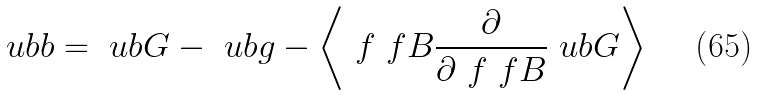<formula> <loc_0><loc_0><loc_500><loc_500>\ u b { b } = \ u b { G } - \ u b { g } - \left \langle \ f { \ f { B } } \frac { \partial } { \partial \ f { \ f { B } } } \ u b { G } \right \rangle</formula> 